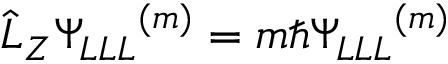<formula> <loc_0><loc_0><loc_500><loc_500>\hat { L } _ { Z } { \Psi _ { L L L } } ^ { ( m ) } = m \hbar { \Psi _ { L L L } } ^ { ( m ) }</formula> 